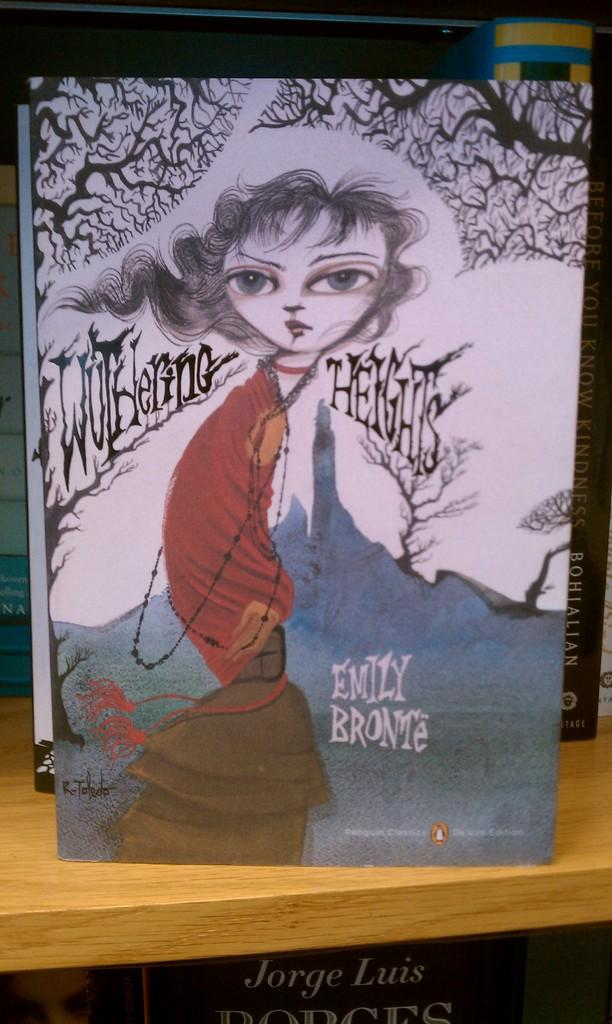<image>
Summarize the visual content of the image. a painting of a girl by emily bronte 